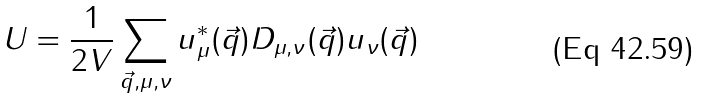Convert formula to latex. <formula><loc_0><loc_0><loc_500><loc_500>U = \frac { 1 } { 2 V } \sum _ { \vec { q } , \mu , \nu } u _ { \mu } ^ { \ast } ( \vec { q } ) D _ { \mu , \nu } ( \vec { q } ) u _ { \nu } ( \vec { q } ) \,</formula> 